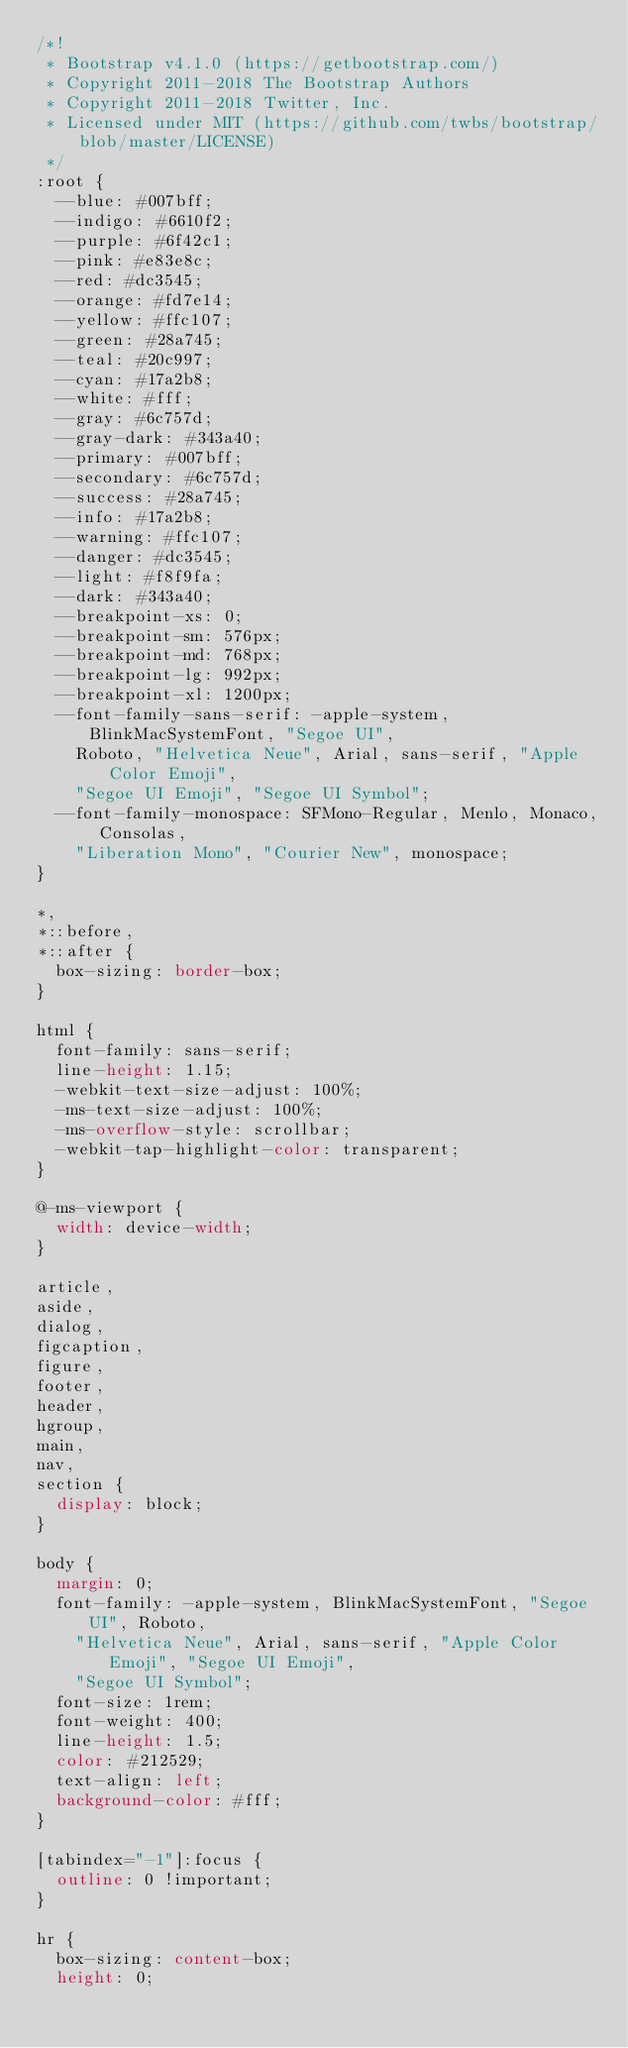Convert code to text. <code><loc_0><loc_0><loc_500><loc_500><_CSS_>/*!
 * Bootstrap v4.1.0 (https://getbootstrap.com/)
 * Copyright 2011-2018 The Bootstrap Authors
 * Copyright 2011-2018 Twitter, Inc.
 * Licensed under MIT (https://github.com/twbs/bootstrap/blob/master/LICENSE)
 */
:root {
  --blue: #007bff;
  --indigo: #6610f2;
  --purple: #6f42c1;
  --pink: #e83e8c;
  --red: #dc3545;
  --orange: #fd7e14;
  --yellow: #ffc107;
  --green: #28a745;
  --teal: #20c997;
  --cyan: #17a2b8;
  --white: #fff;
  --gray: #6c757d;
  --gray-dark: #343a40;
  --primary: #007bff;
  --secondary: #6c757d;
  --success: #28a745;
  --info: #17a2b8;
  --warning: #ffc107;
  --danger: #dc3545;
  --light: #f8f9fa;
  --dark: #343a40;
  --breakpoint-xs: 0;
  --breakpoint-sm: 576px;
  --breakpoint-md: 768px;
  --breakpoint-lg: 992px;
  --breakpoint-xl: 1200px;
  --font-family-sans-serif: -apple-system, BlinkMacSystemFont, "Segoe UI",
    Roboto, "Helvetica Neue", Arial, sans-serif, "Apple Color Emoji",
    "Segoe UI Emoji", "Segoe UI Symbol";
  --font-family-monospace: SFMono-Regular, Menlo, Monaco, Consolas,
    "Liberation Mono", "Courier New", monospace;
}

*,
*::before,
*::after {
  box-sizing: border-box;
}

html {
  font-family: sans-serif;
  line-height: 1.15;
  -webkit-text-size-adjust: 100%;
  -ms-text-size-adjust: 100%;
  -ms-overflow-style: scrollbar;
  -webkit-tap-highlight-color: transparent;
}

@-ms-viewport {
  width: device-width;
}

article,
aside,
dialog,
figcaption,
figure,
footer,
header,
hgroup,
main,
nav,
section {
  display: block;
}

body {
  margin: 0;
  font-family: -apple-system, BlinkMacSystemFont, "Segoe UI", Roboto,
    "Helvetica Neue", Arial, sans-serif, "Apple Color Emoji", "Segoe UI Emoji",
    "Segoe UI Symbol";
  font-size: 1rem;
  font-weight: 400;
  line-height: 1.5;
  color: #212529;
  text-align: left;
  background-color: #fff;
}

[tabindex="-1"]:focus {
  outline: 0 !important;
}

hr {
  box-sizing: content-box;
  height: 0;</code> 